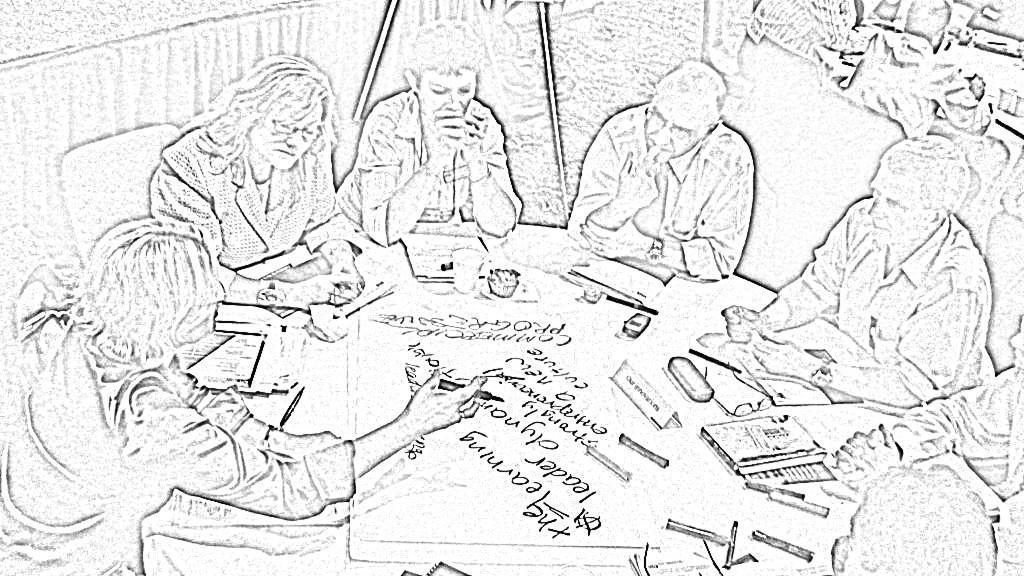Describe this image in one or two sentences. This is a sketch picture. People are sitting on chairs. In-front of them there is a table with objects. 